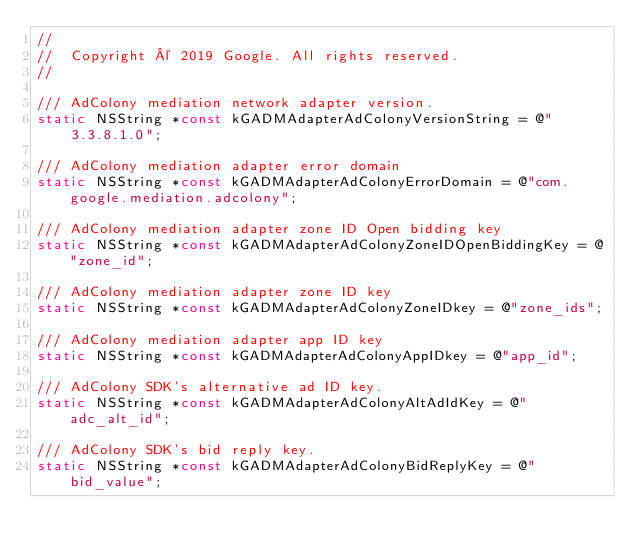<code> <loc_0><loc_0><loc_500><loc_500><_C_>//
//  Copyright © 2019 Google. All rights reserved.
//

/// AdColony mediation network adapter version.
static NSString *const kGADMAdapterAdColonyVersionString = @"3.3.8.1.0";

/// AdColony mediation adapter error domain
static NSString *const kGADMAdapterAdColonyErrorDomain = @"com.google.mediation.adcolony";

/// AdColony mediation adapter zone ID Open bidding key
static NSString *const kGADMAdapterAdColonyZoneIDOpenBiddingKey = @"zone_id";

/// AdColony mediation adapter zone ID key
static NSString *const kGADMAdapterAdColonyZoneIDkey = @"zone_ids";

/// AdColony mediation adapter app ID key
static NSString *const kGADMAdapterAdColonyAppIDkey = @"app_id";

/// AdColony SDK's alternative ad ID key.
static NSString *const kGADMAdapterAdColonyAltAdIdKey = @"adc_alt_id";

/// AdColony SDK's bid reply key.
static NSString *const kGADMAdapterAdColonyBidReplyKey = @"bid_value";
</code> 